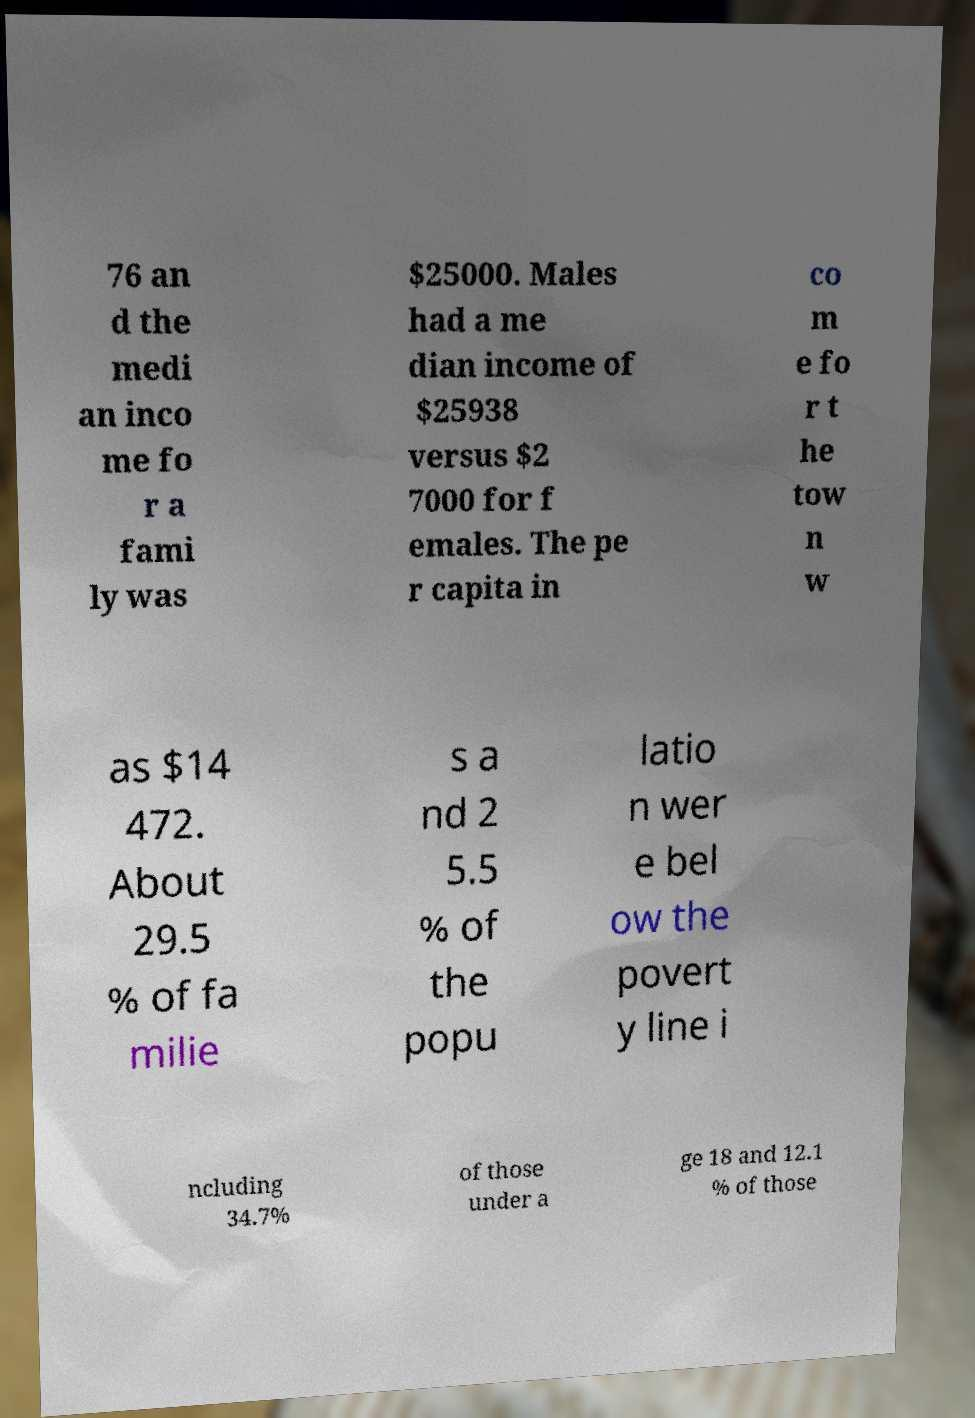I need the written content from this picture converted into text. Can you do that? 76 an d the medi an inco me fo r a fami ly was $25000. Males had a me dian income of $25938 versus $2 7000 for f emales. The pe r capita in co m e fo r t he tow n w as $14 472. About 29.5 % of fa milie s a nd 2 5.5 % of the popu latio n wer e bel ow the povert y line i ncluding 34.7% of those under a ge 18 and 12.1 % of those 